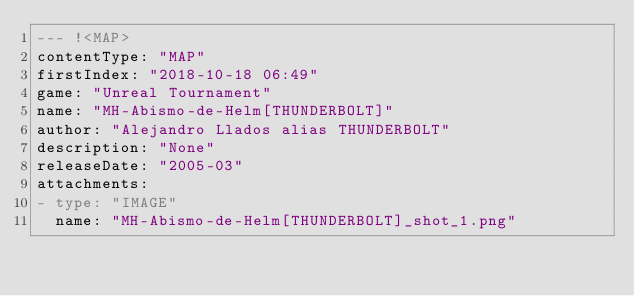Convert code to text. <code><loc_0><loc_0><loc_500><loc_500><_YAML_>--- !<MAP>
contentType: "MAP"
firstIndex: "2018-10-18 06:49"
game: "Unreal Tournament"
name: "MH-Abismo-de-Helm[THUNDERBOLT]"
author: "Alejandro Llados alias THUNDERBOLT"
description: "None"
releaseDate: "2005-03"
attachments:
- type: "IMAGE"
  name: "MH-Abismo-de-Helm[THUNDERBOLT]_shot_1.png"</code> 